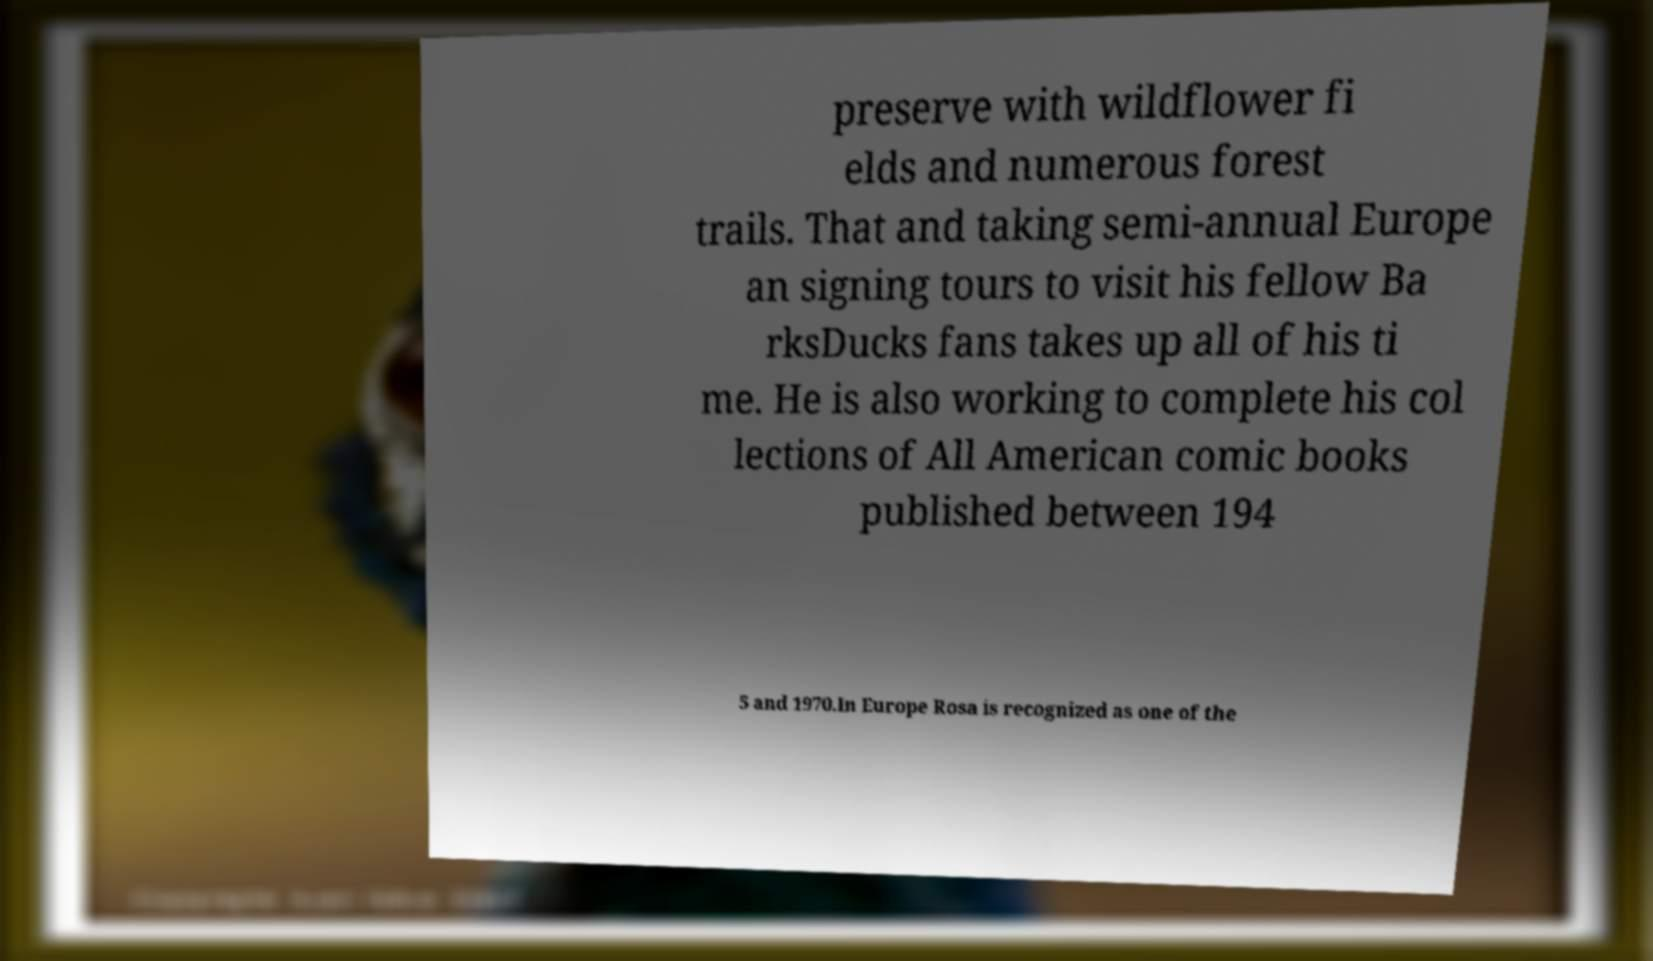Could you assist in decoding the text presented in this image and type it out clearly? preserve with wildflower fi elds and numerous forest trails. That and taking semi-annual Europe an signing tours to visit his fellow Ba rksDucks fans takes up all of his ti me. He is also working to complete his col lections of All American comic books published between 194 5 and 1970.In Europe Rosa is recognized as one of the 